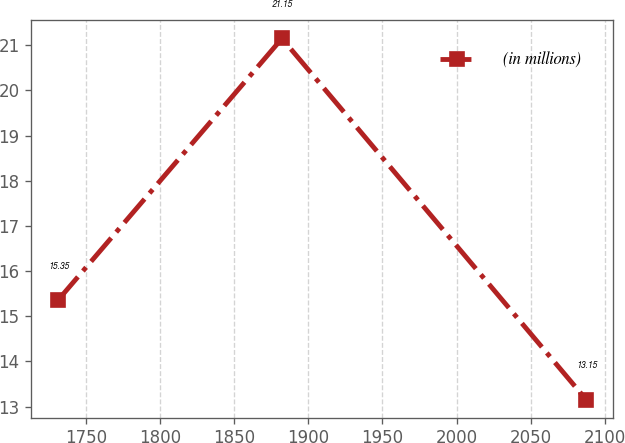Convert chart. <chart><loc_0><loc_0><loc_500><loc_500><line_chart><ecel><fcel>(in millions)<nl><fcel>1731.08<fcel>15.35<nl><fcel>1882.25<fcel>21.15<nl><fcel>2087.49<fcel>13.15<nl></chart> 